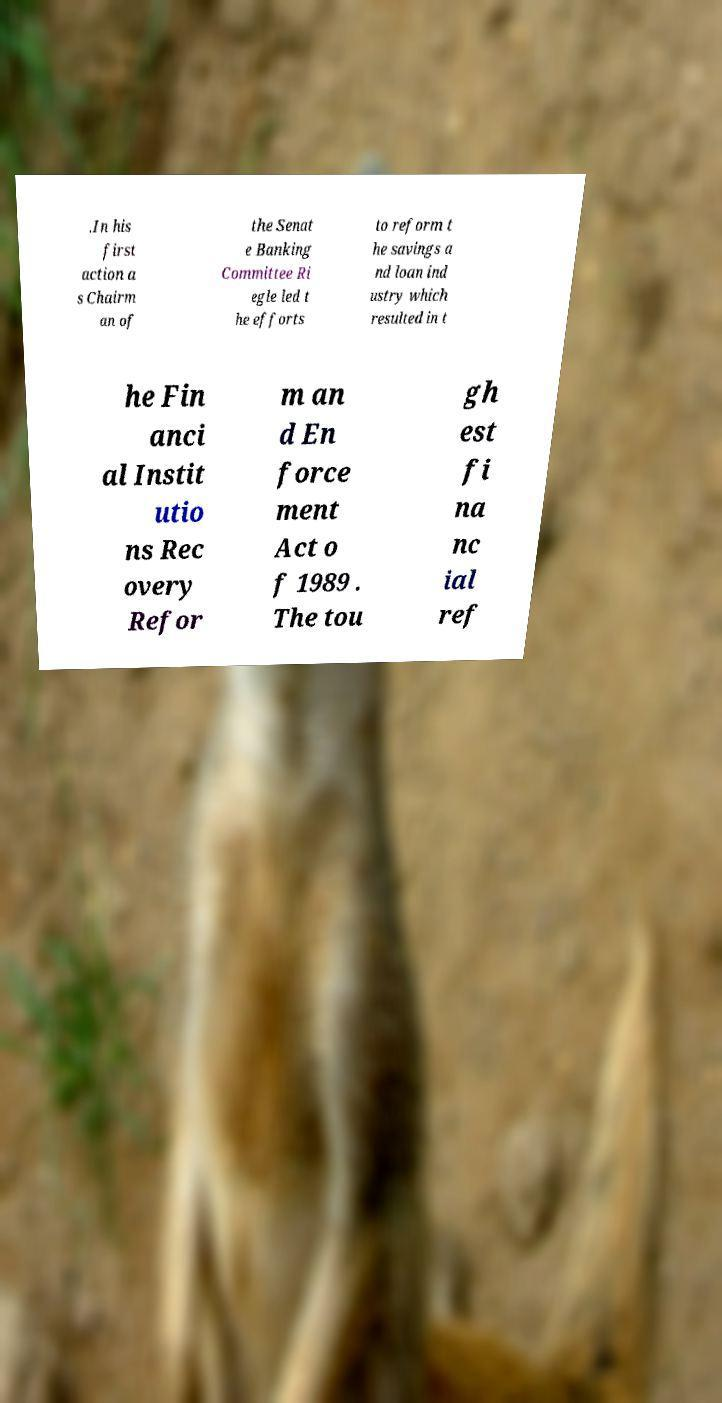For documentation purposes, I need the text within this image transcribed. Could you provide that? .In his first action a s Chairm an of the Senat e Banking Committee Ri egle led t he efforts to reform t he savings a nd loan ind ustry which resulted in t he Fin anci al Instit utio ns Rec overy Refor m an d En force ment Act o f 1989 . The tou gh est fi na nc ial ref 